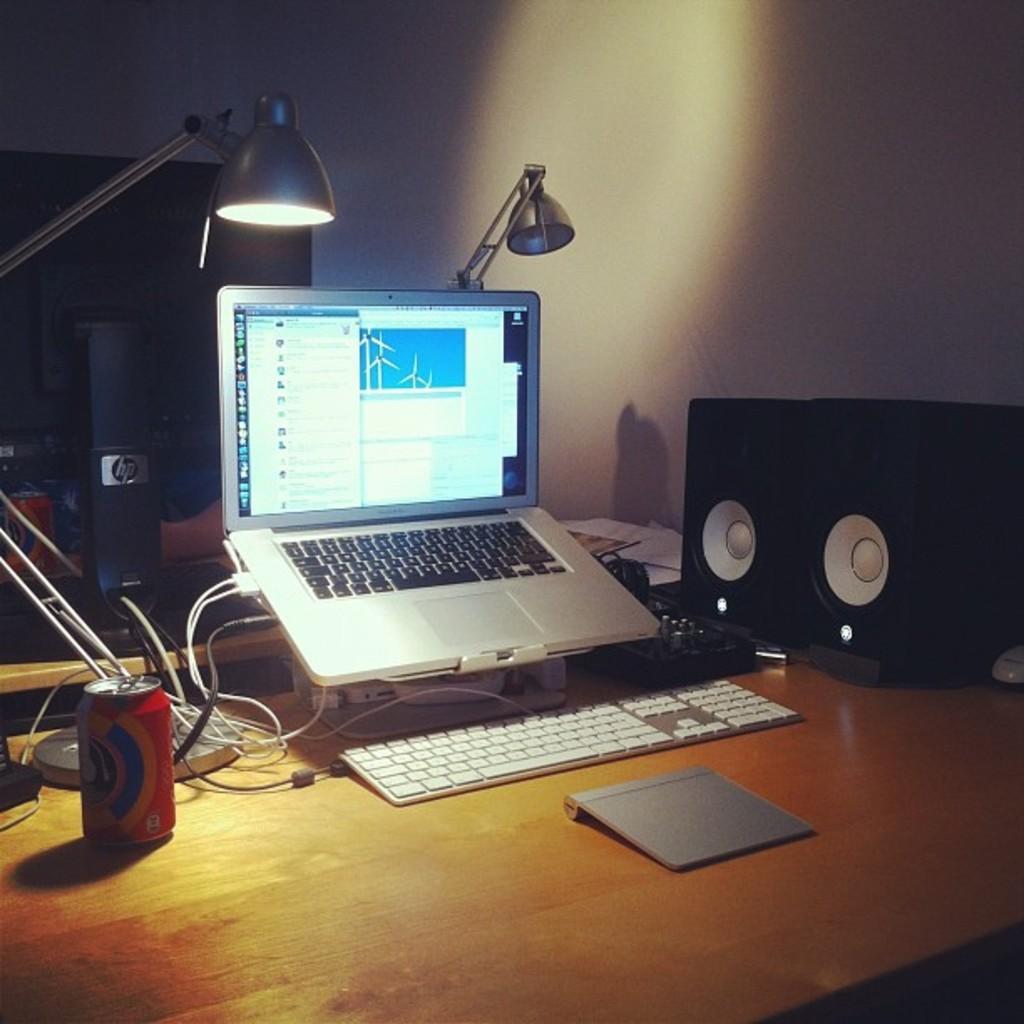How would you summarize this image in a sentence or two? Here we can see a laptop, cable wires, a keyboard, speakers, a tin and light all placed on a table 